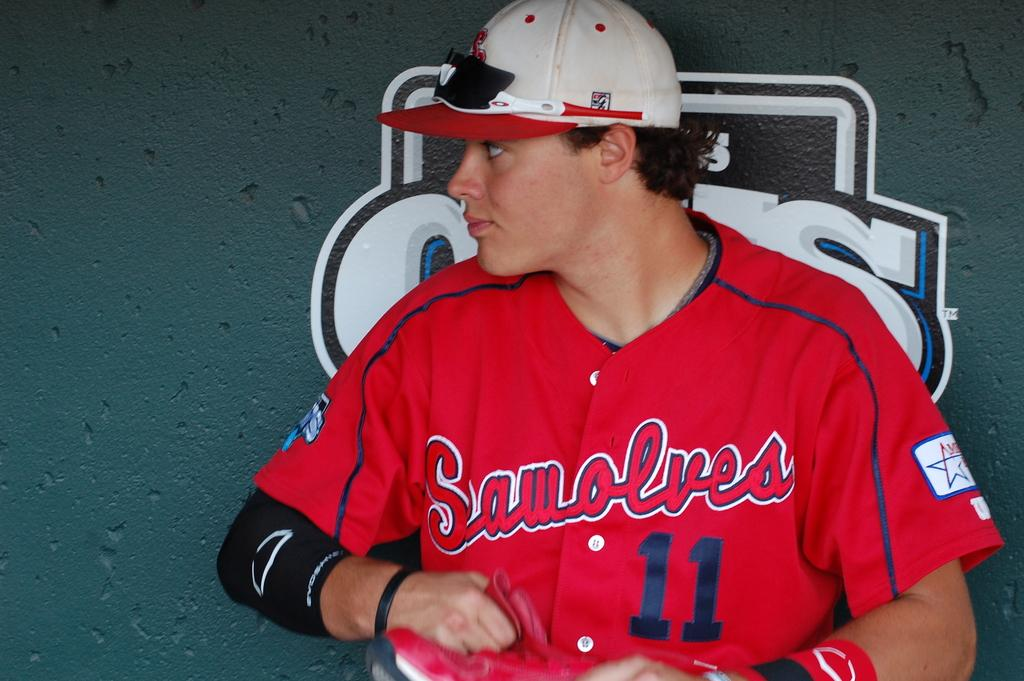Provide a one-sentence caption for the provided image. Team player 11 from the Seawolves sits in the dugout looking to his right. 